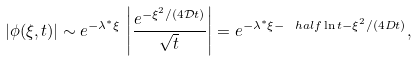<formula> <loc_0><loc_0><loc_500><loc_500>| \phi ( \xi , t ) | \sim e ^ { - \lambda ^ { * } \xi } \, \left | \frac { e ^ { - \xi ^ { 2 } / ( 4 { \mathcal { D } } t ) } } { \sqrt { t } } \right | = e ^ { - \lambda ^ { * } \xi - \ h a l f \ln t - \xi ^ { 2 } / ( 4 D t ) } ,</formula> 